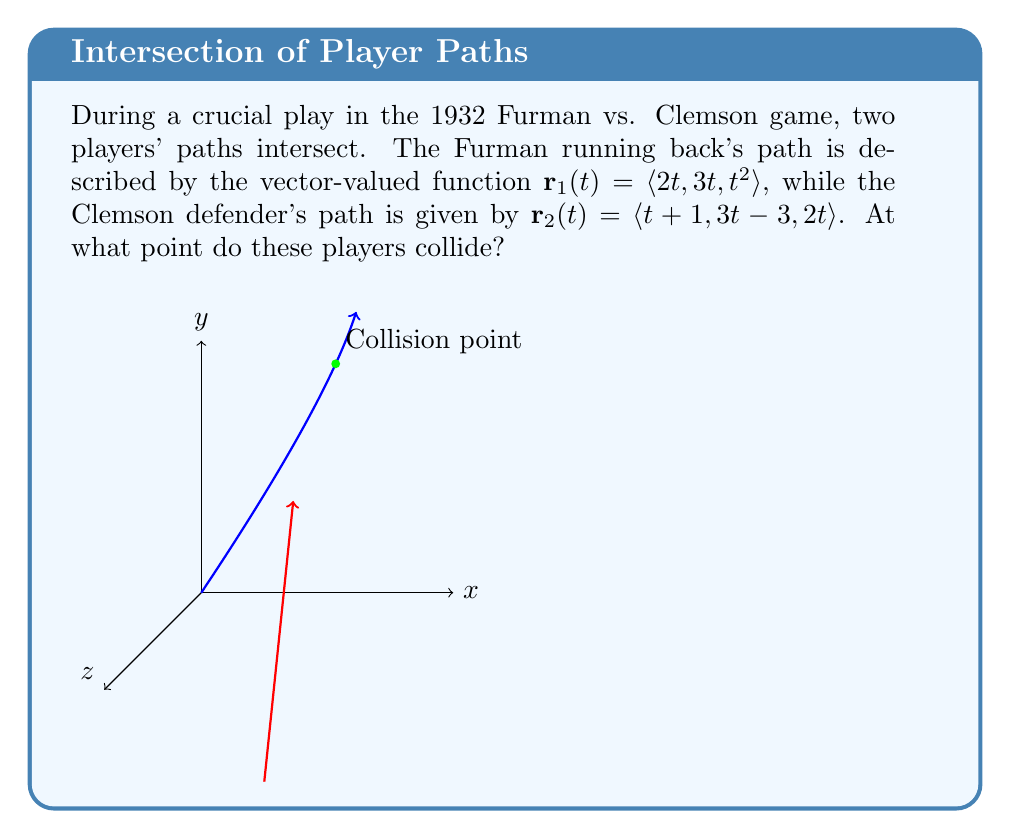Provide a solution to this math problem. To find the intersection point, we need to equate the components of both vector-valued functions:

1) Equate x-components:
   $2t = t + 1$
   $t = 1$

2) Verify y-components:
   At $t = 1$: $3(1) = 3(1) - 3$
   $3 = 0$ (This doesn't match)

3) Verify z-components:
   At $t = 1$: $1^2 \neq 2(1)$
   $1 \neq 2$ (This doesn't match)

The mismatch indicates that we need to use different t-values for each function. Let's call them $t_1$ for $\mathbf{r}_1$ and $t_2$ for $\mathbf{r}_2$.

4) Set up the system of equations:
   $2t_1 = t_2 + 1$
   $3t_1 = 3t_2 - 3$
   $t_1^2 = 2t_2$

5) From the second equation:
   $t_1 = t_2 - 1$

6) Substitute this into the first equation:
   $2(t_2 - 1) = t_2 + 1$
   $2t_2 - 2 = t_2 + 1$
   $t_2 = 3$

7) Therefore, $t_1 = 3 - 1 = 2$

8) Verify using the third equation:
   $2^2 = 2(3)$
   $4 = 6$ (This matches)

9) Calculate the intersection point using either function with its corresponding t-value:
   $\mathbf{r}_1(2) = \langle 2(2), 3(2), 2^2 \rangle = \langle 4, 6, 4 \rangle$
   or
   $\mathbf{r}_2(3) = \langle 3+1, 3(3)-3, 2(3) \rangle = \langle 4, 6, 6 \rangle$
Answer: $\langle 4, 6, 4 \rangle$ 